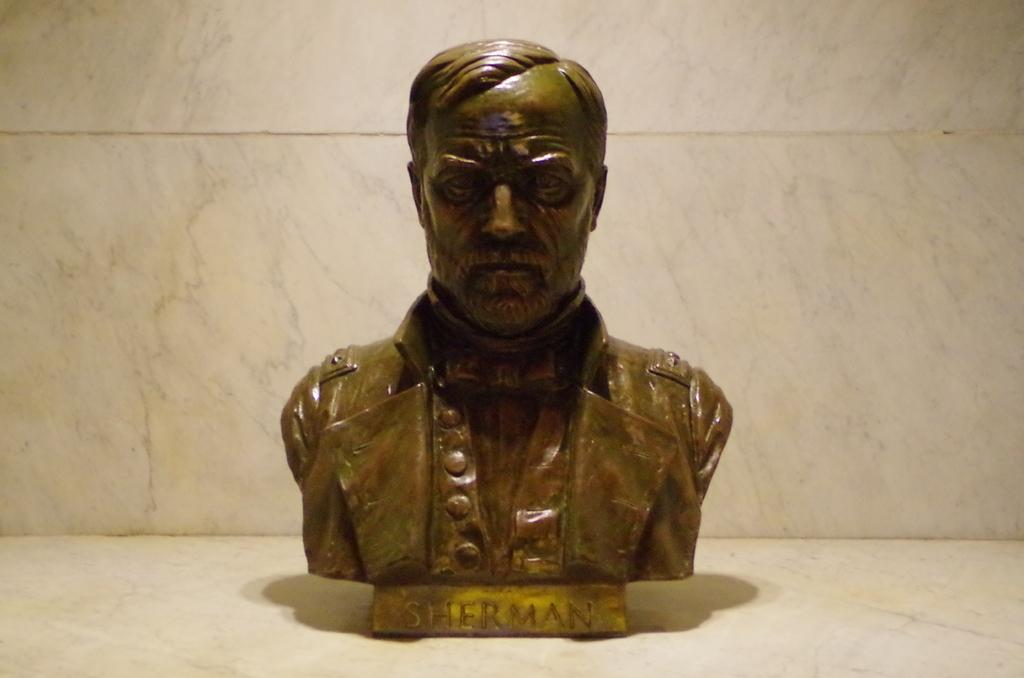What is the main subject of the image? There is a statue of a person in the image. Where is the statue located? The statue is on the floor. What can be seen in the background of the image? There is a white wall in the background of the image. What team does the person in the statue represent? The image does not provide any information about a team or the person's representation, as it only shows a statue of a person on the floor with a white wall in the background. 